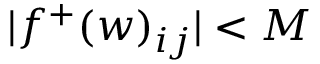Convert formula to latex. <formula><loc_0><loc_0><loc_500><loc_500>| f ^ { + } ( w ) _ { i j } | < M</formula> 